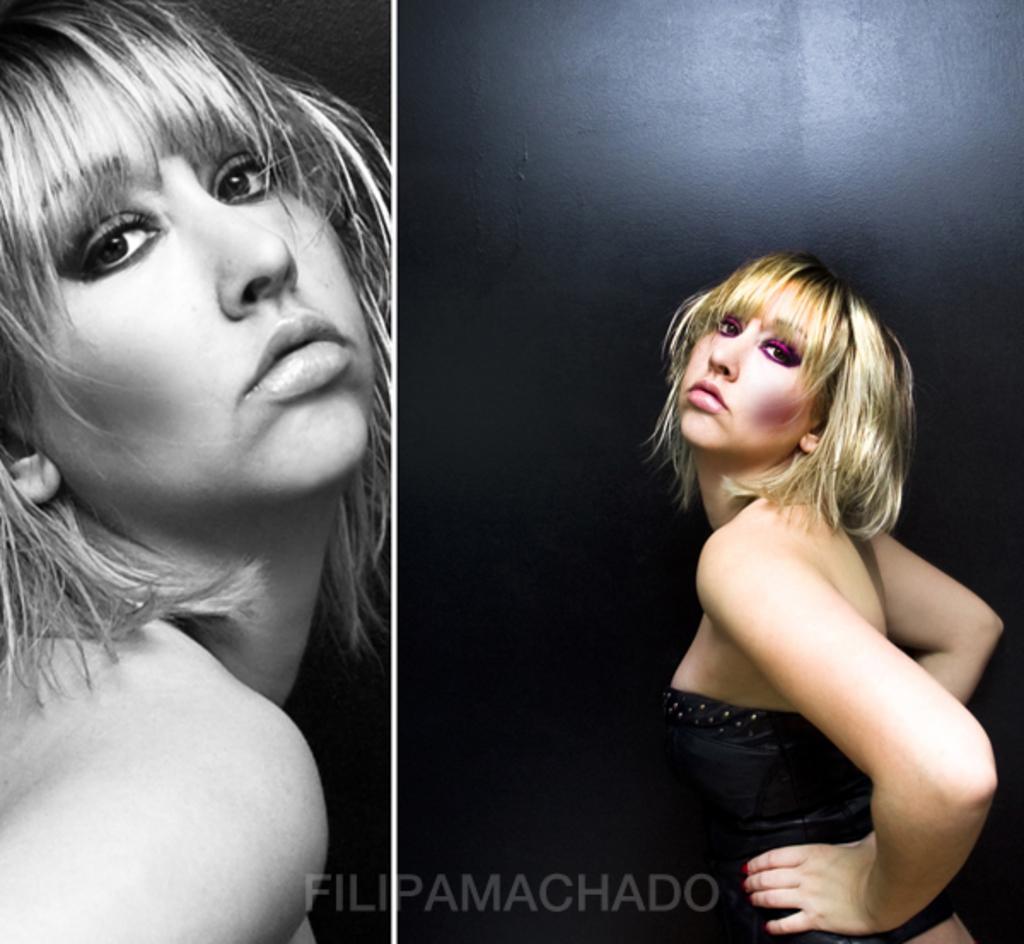Could you give a brief overview of what you see in this image? In this image I can see a collage picture of the same person. In the background of the image it is dark. At the bottom of the image there is a watermark. 